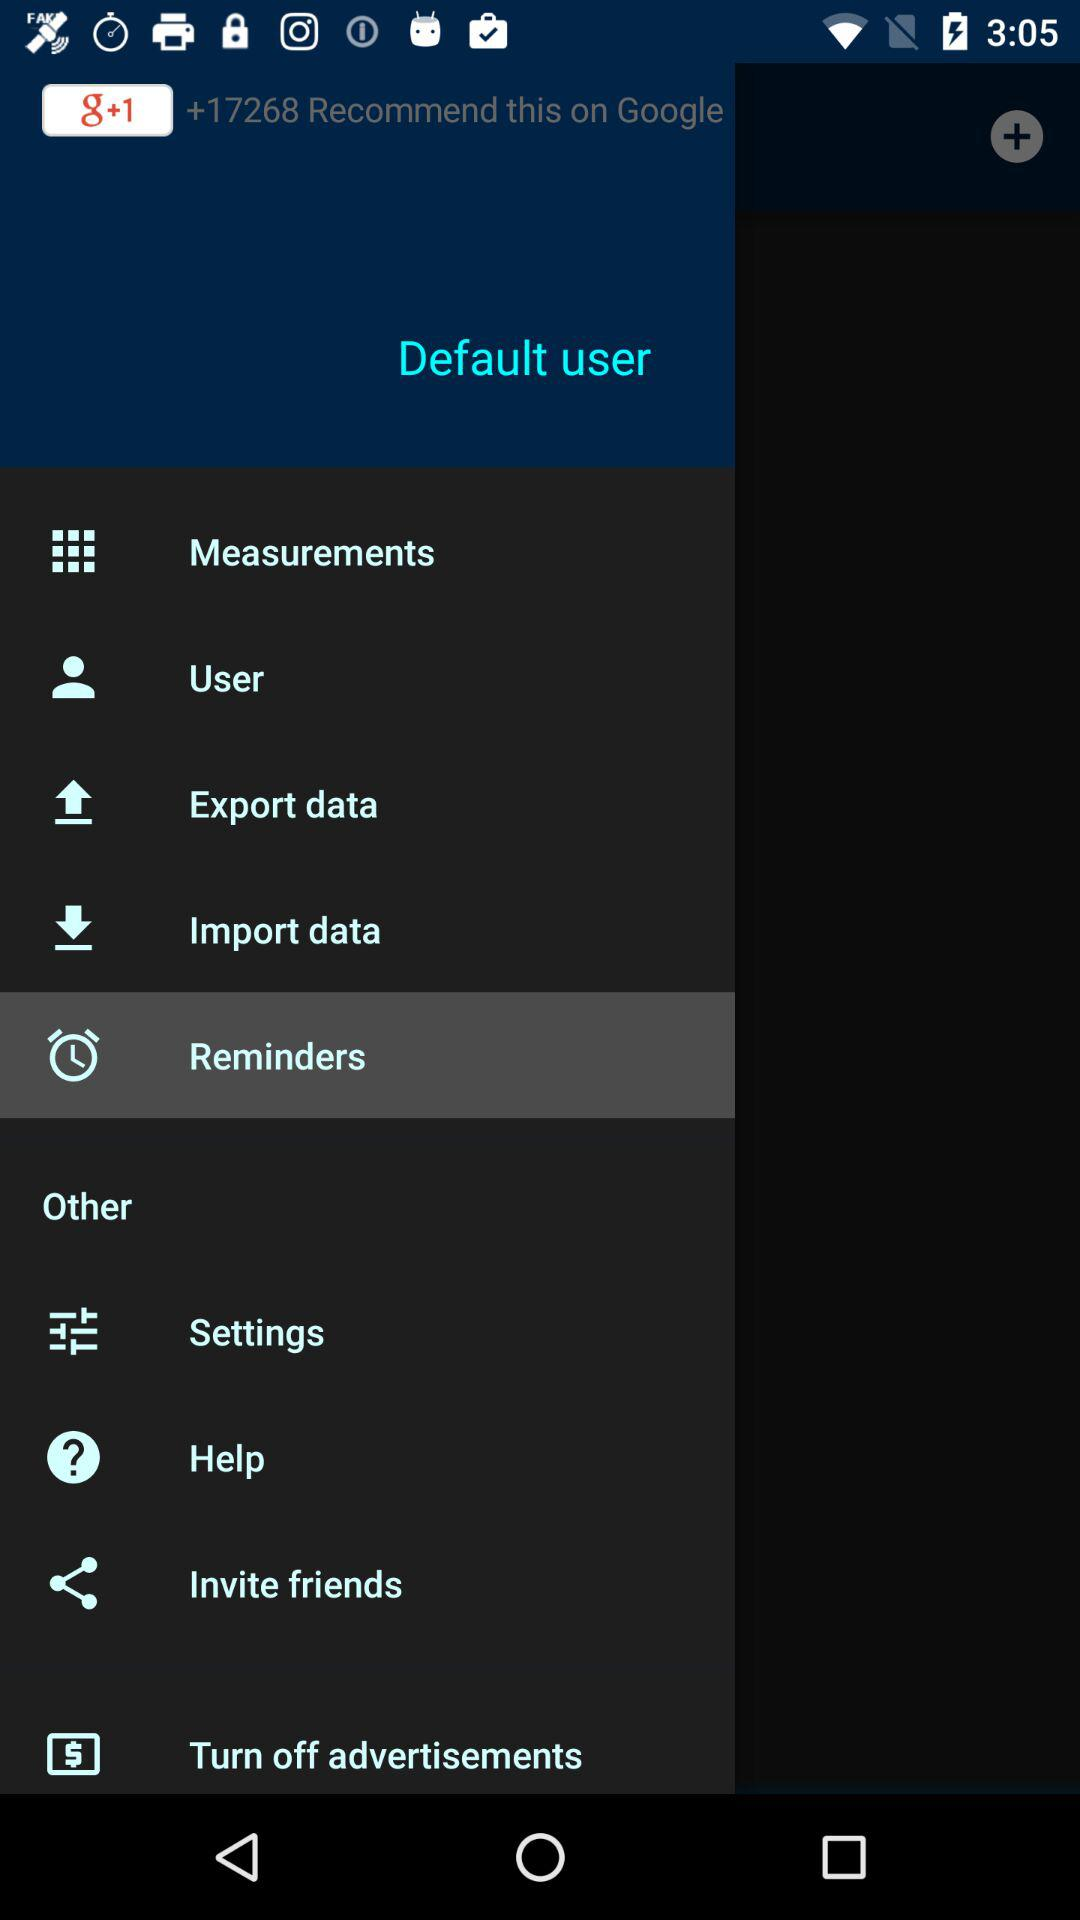Which item is selected in the menu? The selected item in the menu is "Reminders". 